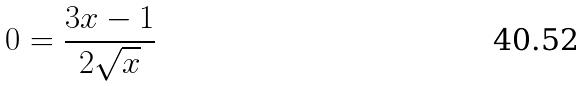<formula> <loc_0><loc_0><loc_500><loc_500>0 = \frac { 3 x - 1 } { 2 \sqrt { x } }</formula> 